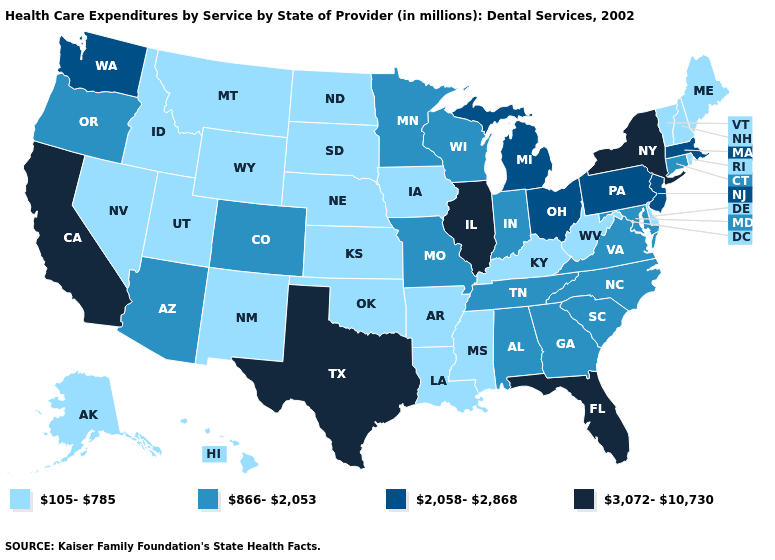Name the states that have a value in the range 866-2,053?
Keep it brief. Alabama, Arizona, Colorado, Connecticut, Georgia, Indiana, Maryland, Minnesota, Missouri, North Carolina, Oregon, South Carolina, Tennessee, Virginia, Wisconsin. Does South Dakota have the lowest value in the MidWest?
Give a very brief answer. Yes. What is the highest value in the MidWest ?
Quick response, please. 3,072-10,730. What is the value of Kentucky?
Quick response, please. 105-785. Does Delaware have the same value as Florida?
Answer briefly. No. Does the first symbol in the legend represent the smallest category?
Be succinct. Yes. Among the states that border Pennsylvania , does Delaware have the lowest value?
Short answer required. Yes. What is the lowest value in states that border Michigan?
Be succinct. 866-2,053. Does Texas have the same value as Michigan?
Be succinct. No. What is the value of Indiana?
Short answer required. 866-2,053. Name the states that have a value in the range 866-2,053?
Concise answer only. Alabama, Arizona, Colorado, Connecticut, Georgia, Indiana, Maryland, Minnesota, Missouri, North Carolina, Oregon, South Carolina, Tennessee, Virginia, Wisconsin. Name the states that have a value in the range 3,072-10,730?
Be succinct. California, Florida, Illinois, New York, Texas. What is the lowest value in states that border West Virginia?
Keep it brief. 105-785. Name the states that have a value in the range 866-2,053?
Quick response, please. Alabama, Arizona, Colorado, Connecticut, Georgia, Indiana, Maryland, Minnesota, Missouri, North Carolina, Oregon, South Carolina, Tennessee, Virginia, Wisconsin. Name the states that have a value in the range 866-2,053?
Quick response, please. Alabama, Arizona, Colorado, Connecticut, Georgia, Indiana, Maryland, Minnesota, Missouri, North Carolina, Oregon, South Carolina, Tennessee, Virginia, Wisconsin. 